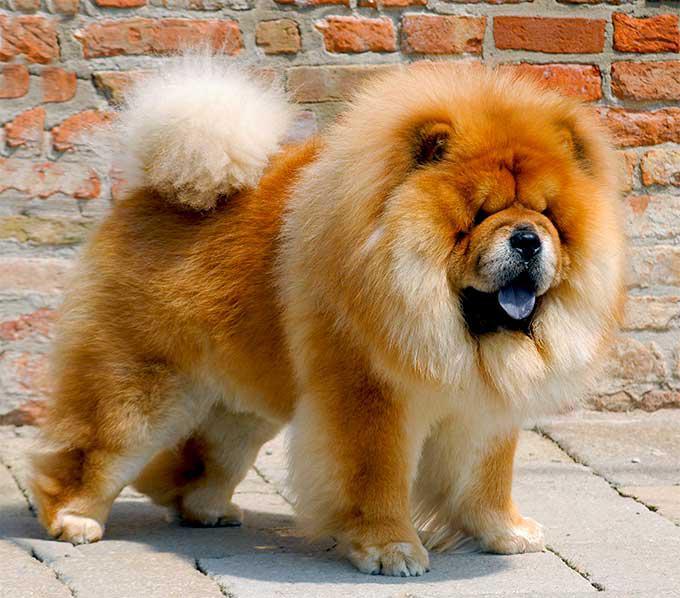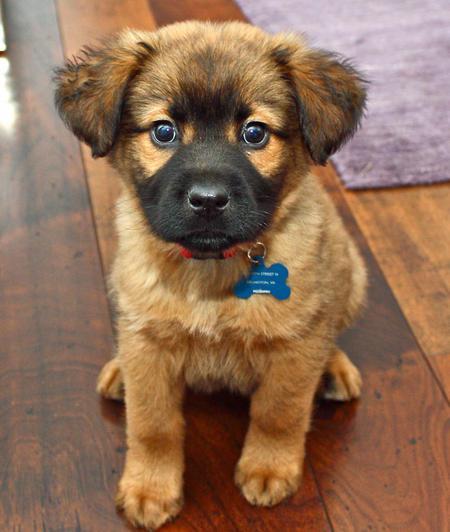The first image is the image on the left, the second image is the image on the right. Evaluate the accuracy of this statement regarding the images: "There are three dogs". Is it true? Answer yes or no. No. 